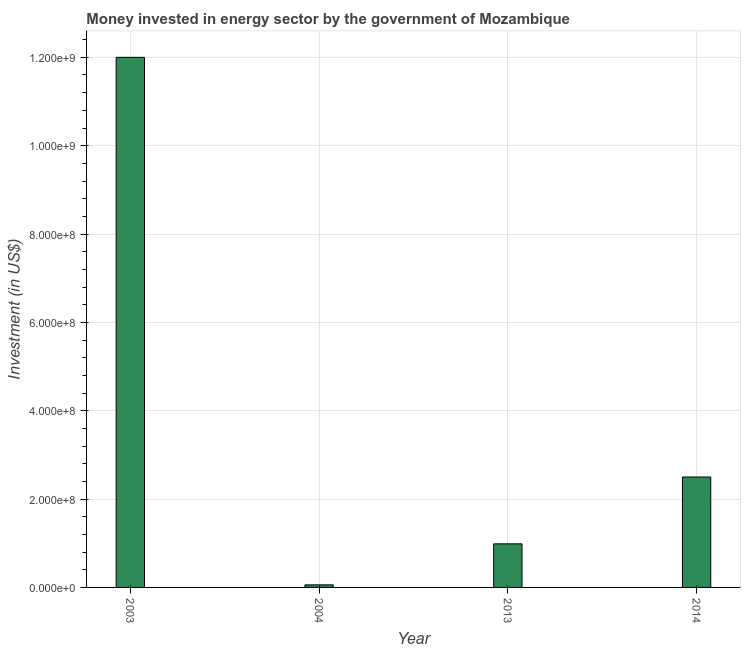Does the graph contain any zero values?
Ensure brevity in your answer.  No. What is the title of the graph?
Give a very brief answer. Money invested in energy sector by the government of Mozambique. What is the label or title of the X-axis?
Give a very brief answer. Year. What is the label or title of the Y-axis?
Keep it short and to the point. Investment (in US$). What is the investment in energy in 2014?
Provide a succinct answer. 2.50e+08. Across all years, what is the maximum investment in energy?
Your answer should be very brief. 1.20e+09. Across all years, what is the minimum investment in energy?
Your answer should be very brief. 5.80e+06. In which year was the investment in energy maximum?
Your response must be concise. 2003. In which year was the investment in energy minimum?
Offer a terse response. 2004. What is the sum of the investment in energy?
Provide a succinct answer. 1.55e+09. What is the difference between the investment in energy in 2003 and 2014?
Your response must be concise. 9.50e+08. What is the average investment in energy per year?
Give a very brief answer. 3.89e+08. What is the median investment in energy?
Your answer should be compact. 1.74e+08. Do a majority of the years between 2013 and 2004 (inclusive) have investment in energy greater than 600000000 US$?
Offer a terse response. No. What is the ratio of the investment in energy in 2013 to that in 2014?
Give a very brief answer. 0.4. Is the difference between the investment in energy in 2004 and 2013 greater than the difference between any two years?
Offer a very short reply. No. What is the difference between the highest and the second highest investment in energy?
Provide a succinct answer. 9.50e+08. Is the sum of the investment in energy in 2003 and 2004 greater than the maximum investment in energy across all years?
Provide a short and direct response. Yes. What is the difference between the highest and the lowest investment in energy?
Your answer should be compact. 1.19e+09. In how many years, is the investment in energy greater than the average investment in energy taken over all years?
Ensure brevity in your answer.  1. How many years are there in the graph?
Provide a short and direct response. 4. What is the difference between two consecutive major ticks on the Y-axis?
Keep it short and to the point. 2.00e+08. What is the Investment (in US$) in 2003?
Your answer should be very brief. 1.20e+09. What is the Investment (in US$) of 2004?
Make the answer very short. 5.80e+06. What is the Investment (in US$) in 2013?
Offer a terse response. 9.87e+07. What is the Investment (in US$) in 2014?
Make the answer very short. 2.50e+08. What is the difference between the Investment (in US$) in 2003 and 2004?
Your answer should be compact. 1.19e+09. What is the difference between the Investment (in US$) in 2003 and 2013?
Offer a very short reply. 1.10e+09. What is the difference between the Investment (in US$) in 2003 and 2014?
Ensure brevity in your answer.  9.50e+08. What is the difference between the Investment (in US$) in 2004 and 2013?
Make the answer very short. -9.29e+07. What is the difference between the Investment (in US$) in 2004 and 2014?
Ensure brevity in your answer.  -2.44e+08. What is the difference between the Investment (in US$) in 2013 and 2014?
Give a very brief answer. -1.51e+08. What is the ratio of the Investment (in US$) in 2003 to that in 2004?
Make the answer very short. 206.9. What is the ratio of the Investment (in US$) in 2003 to that in 2013?
Ensure brevity in your answer.  12.16. What is the ratio of the Investment (in US$) in 2004 to that in 2013?
Keep it short and to the point. 0.06. What is the ratio of the Investment (in US$) in 2004 to that in 2014?
Your response must be concise. 0.02. What is the ratio of the Investment (in US$) in 2013 to that in 2014?
Give a very brief answer. 0.4. 